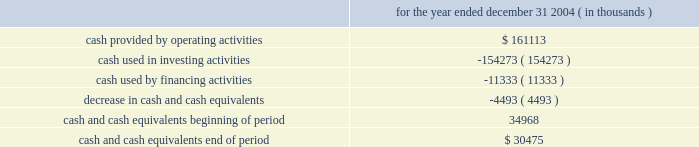The internal revenue code .
Therefore , cash needed to execute our strategy and invest in new properties , as well as to pay our debt at maturity , must come from one or more of the following sources : 2022 cash not distributed to shareholders , 2022 proceeds of property dispositions , or 2022 proceeds derived from the issuance of new debt or equity securities .
It is management 2019s intention that we continually have access to the capital resources necessary to expand and develop our business .
As a result , we intend to operate with and maintain a conservative capital structure that will allow us to maintain strong debt service coverage and fixed-charge coverage ratios as part of our commitment to investment-grade debt ratings .
We may , from time to time , seek to obtain funds by the following means : 2022 additional equity offerings , 2022 unsecured debt financing and/or mortgage financings , and 2022 other debt and equity alternatives , including formation of joint ventures , in a manner consistent with our intention to operate with a conservative debt structure .
Cash and cash equivalents were $ 30.5 million and $ 35.0 million at december 31 , 2004 and december 31 , 2003 , respectively .
Summary of cash flows for the year ended december 31 , 2004 ( in thousands ) .
The cash provided by operating activities is primarily attributable to the operation of our properties and the change in working capital related to our operations .
We used cash of $ 154.3 million during the twelve months ended december 31 , 2004 in investing activities , including the following : 2022 $ 101.7 million for our acquisition of westgate mall , shaw 2019s plaza and several parcels of land , 2022 capital expenditures of $ 59.2 million for development and redevelopment of properties including santana row , 2022 maintenance capital expenditures of approximately $ 36.9 million , 2022 $ 9.4 million capital contribution to a real estate partnership , and 2022 an additional $ 3.2 million net advance under an existing mortgage note receivable ; offset by 2022 $ 41.8 million in net sale proceeds from the sale of properties , and .
What was the percentual decrease in the cash and cash equivalents during this period? 
Rationale: it is the amount of the decrease in cash and cash equivalents divided by the cash and cash equivalents at the beginning of the period , then turned into a percentage .
Computations: (4493 / 34968)
Answer: 0.12849. 